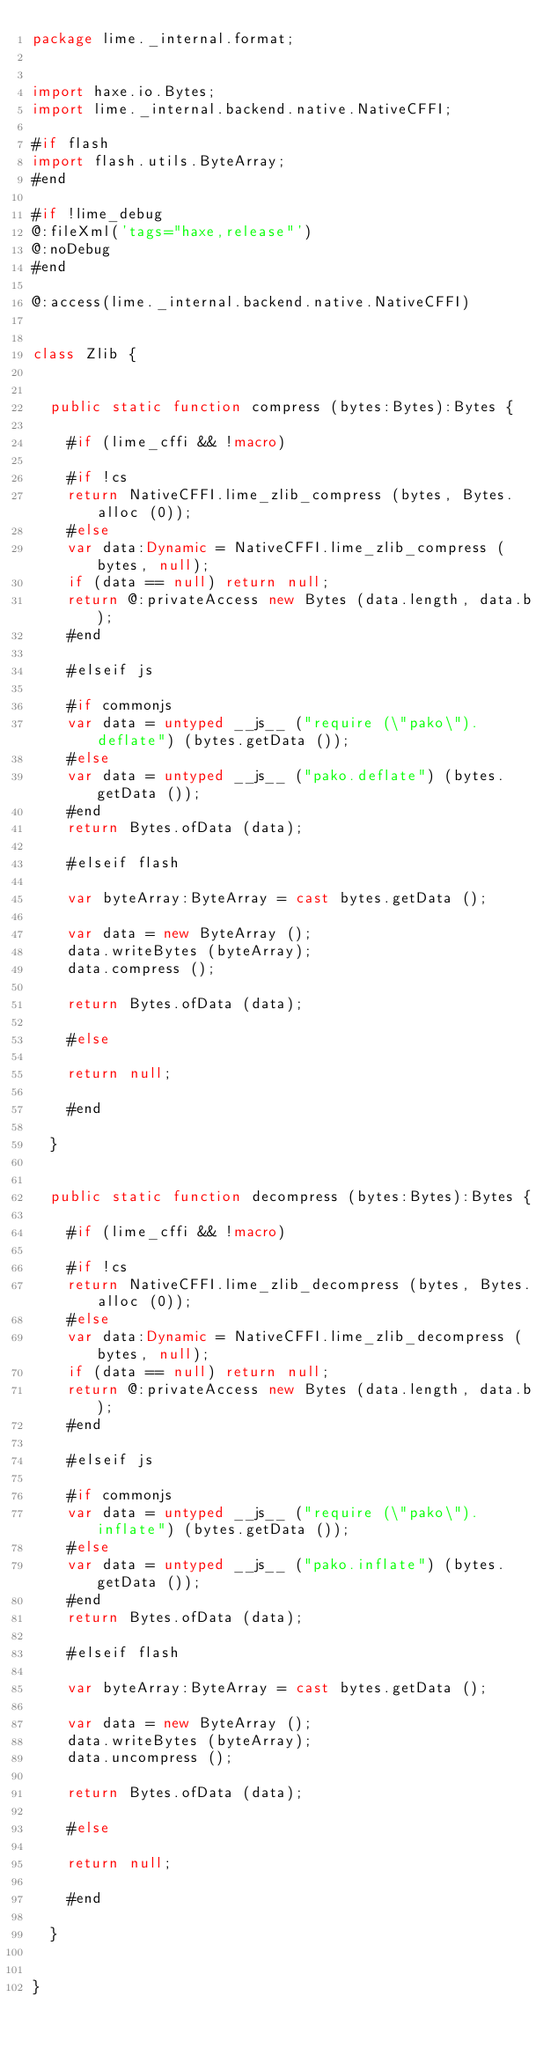<code> <loc_0><loc_0><loc_500><loc_500><_Haxe_>package lime._internal.format;


import haxe.io.Bytes;
import lime._internal.backend.native.NativeCFFI;

#if flash
import flash.utils.ByteArray;
#end

#if !lime_debug
@:fileXml('tags="haxe,release"')
@:noDebug
#end

@:access(lime._internal.backend.native.NativeCFFI)


class Zlib {
	
	
	public static function compress (bytes:Bytes):Bytes {
		
		#if (lime_cffi && !macro)
		
		#if !cs
		return NativeCFFI.lime_zlib_compress (bytes, Bytes.alloc (0));
		#else
		var data:Dynamic = NativeCFFI.lime_zlib_compress (bytes, null);
		if (data == null) return null;
		return @:privateAccess new Bytes (data.length, data.b);
		#end
		
		#elseif js
		
		#if commonjs
		var data = untyped __js__ ("require (\"pako\").deflate") (bytes.getData ());
		#else
		var data = untyped __js__ ("pako.deflate") (bytes.getData ());
		#end
		return Bytes.ofData (data);
		
		#elseif flash
		
		var byteArray:ByteArray = cast bytes.getData ();
		
		var data = new ByteArray ();
		data.writeBytes (byteArray);
		data.compress ();
		
		return Bytes.ofData (data);
		
		#else
		
		return null;
		
		#end
		
	}
	
	
	public static function decompress (bytes:Bytes):Bytes {
		
		#if (lime_cffi && !macro)
		
		#if !cs
		return NativeCFFI.lime_zlib_decompress (bytes, Bytes.alloc (0));
		#else
		var data:Dynamic = NativeCFFI.lime_zlib_decompress (bytes, null);
		if (data == null) return null;
		return @:privateAccess new Bytes (data.length, data.b);
		#end
		
		#elseif js
		
		#if commonjs
		var data = untyped __js__ ("require (\"pako\").inflate") (bytes.getData ());
		#else
		var data = untyped __js__ ("pako.inflate") (bytes.getData ());
		#end
		return Bytes.ofData (data);
		
		#elseif flash
		
		var byteArray:ByteArray = cast bytes.getData ();
		
		var data = new ByteArray ();
		data.writeBytes (byteArray);
		data.uncompress ();
		
		return Bytes.ofData (data);
		
		#else
		
		return null;
		
		#end
		
	}
	
	
}</code> 